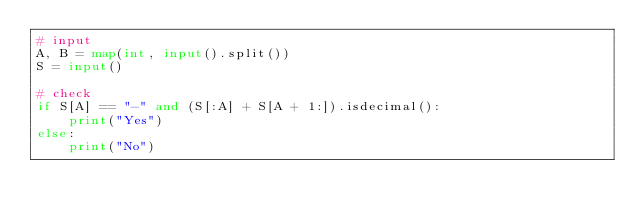<code> <loc_0><loc_0><loc_500><loc_500><_Python_># input
A, B = map(int, input().split())
S = input()

# check
if S[A] == "-" and (S[:A] + S[A + 1:]).isdecimal():
    print("Yes")
else:
    print("No")</code> 